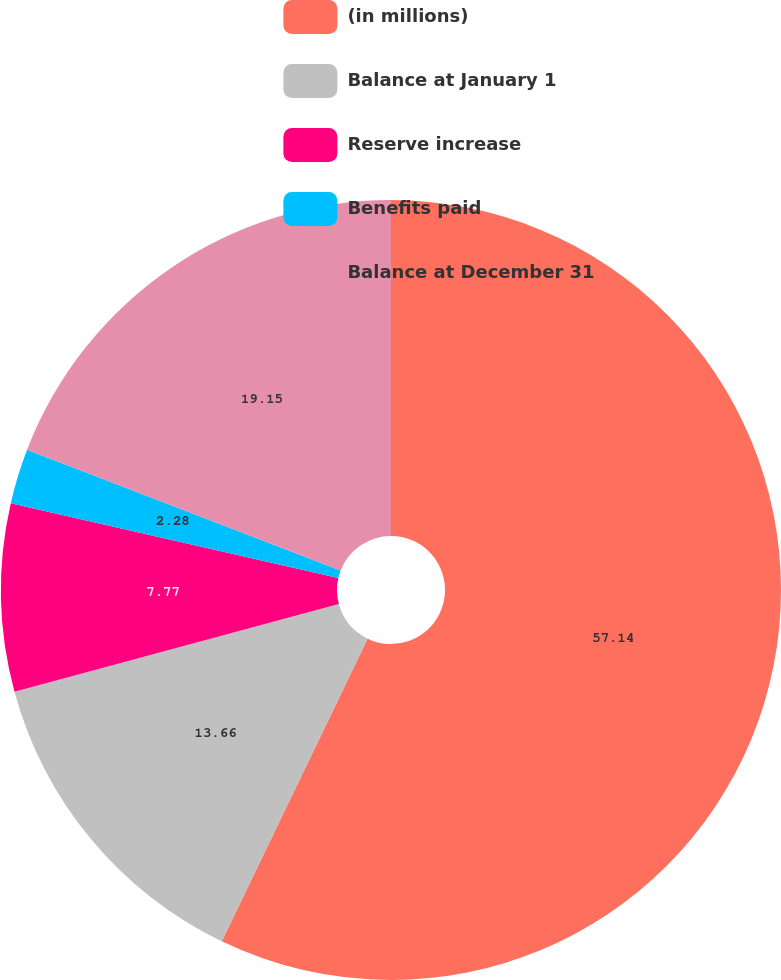Convert chart to OTSL. <chart><loc_0><loc_0><loc_500><loc_500><pie_chart><fcel>(in millions)<fcel>Balance at January 1<fcel>Reserve increase<fcel>Benefits paid<fcel>Balance at December 31<nl><fcel>57.15%<fcel>13.66%<fcel>7.77%<fcel>2.28%<fcel>19.15%<nl></chart> 